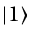Convert formula to latex. <formula><loc_0><loc_0><loc_500><loc_500>| 1 \rangle</formula> 